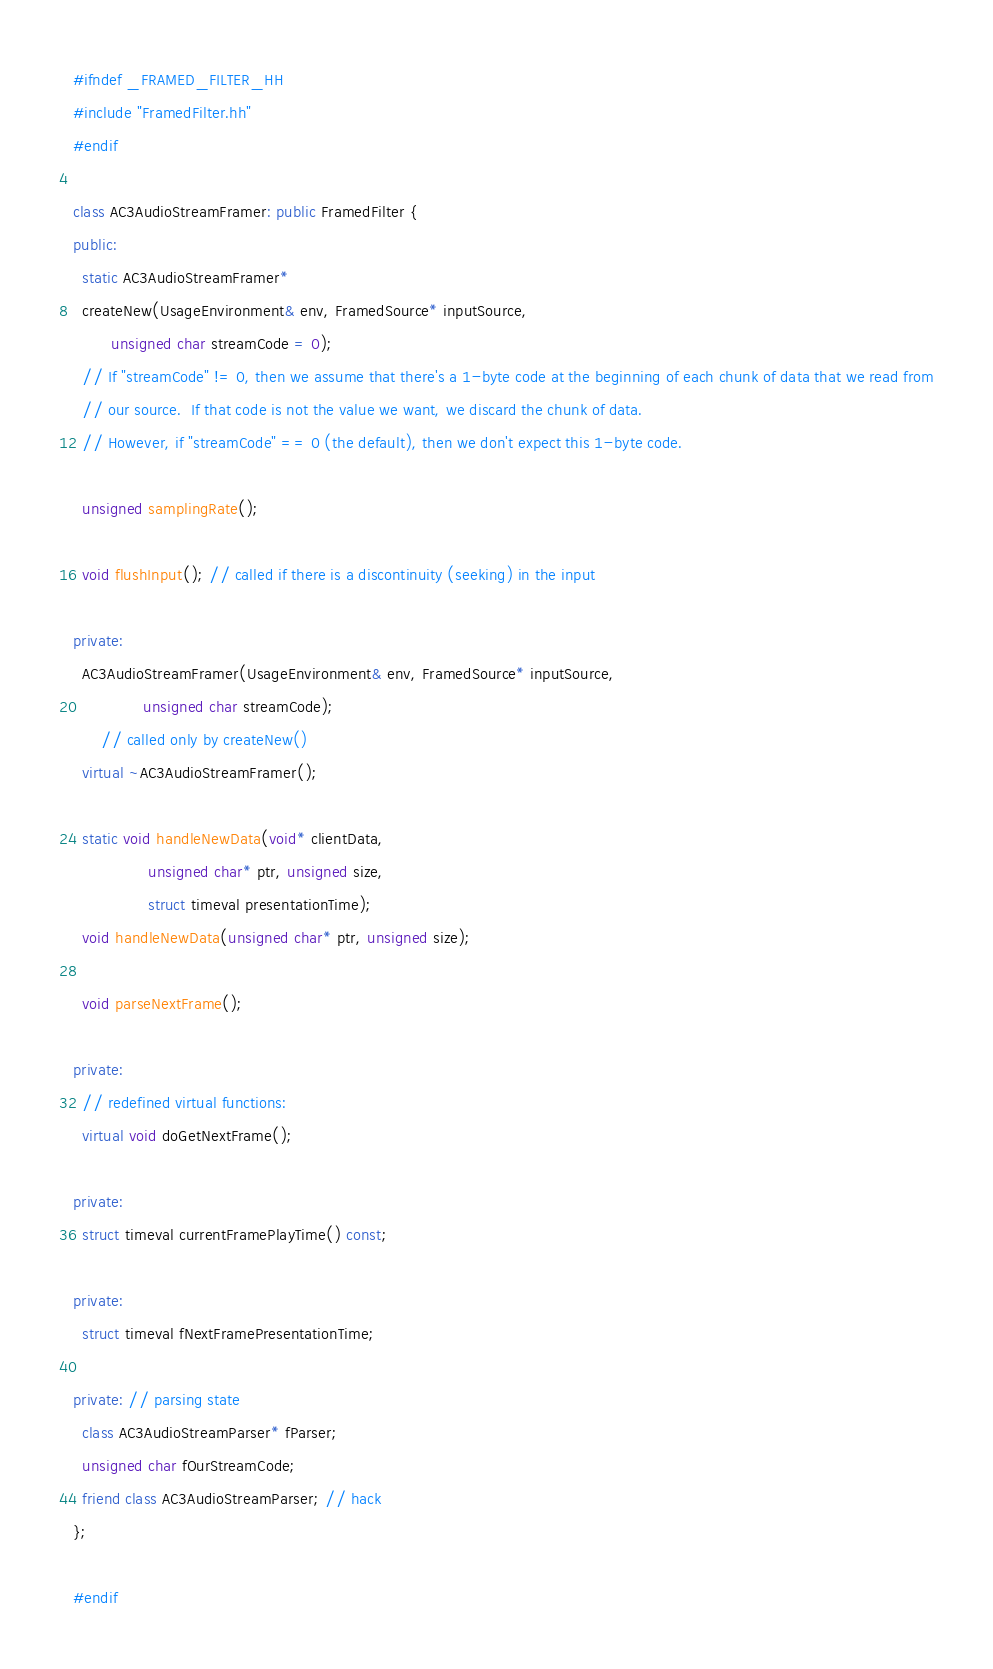Convert code to text. <code><loc_0><loc_0><loc_500><loc_500><_C++_>#ifndef _FRAMED_FILTER_HH
#include "FramedFilter.hh"
#endif

class AC3AudioStreamFramer: public FramedFilter {
public:
  static AC3AudioStreamFramer*
  createNew(UsageEnvironment& env, FramedSource* inputSource,
	    unsigned char streamCode = 0);
  // If "streamCode" != 0, then we assume that there's a 1-byte code at the beginning of each chunk of data that we read from
  // our source.  If that code is not the value we want, we discard the chunk of data.
  // However, if "streamCode" == 0 (the default), then we don't expect this 1-byte code.

  unsigned samplingRate();

  void flushInput(); // called if there is a discontinuity (seeking) in the input

private:
  AC3AudioStreamFramer(UsageEnvironment& env, FramedSource* inputSource,
		       unsigned char streamCode);
      // called only by createNew()
  virtual ~AC3AudioStreamFramer();

  static void handleNewData(void* clientData,
			    unsigned char* ptr, unsigned size,
			    struct timeval presentationTime);
  void handleNewData(unsigned char* ptr, unsigned size);

  void parseNextFrame();

private:
  // redefined virtual functions:
  virtual void doGetNextFrame();

private:
  struct timeval currentFramePlayTime() const;

private:
  struct timeval fNextFramePresentationTime;

private: // parsing state
  class AC3AudioStreamParser* fParser;
  unsigned char fOurStreamCode;
  friend class AC3AudioStreamParser; // hack
};

#endif
</code> 